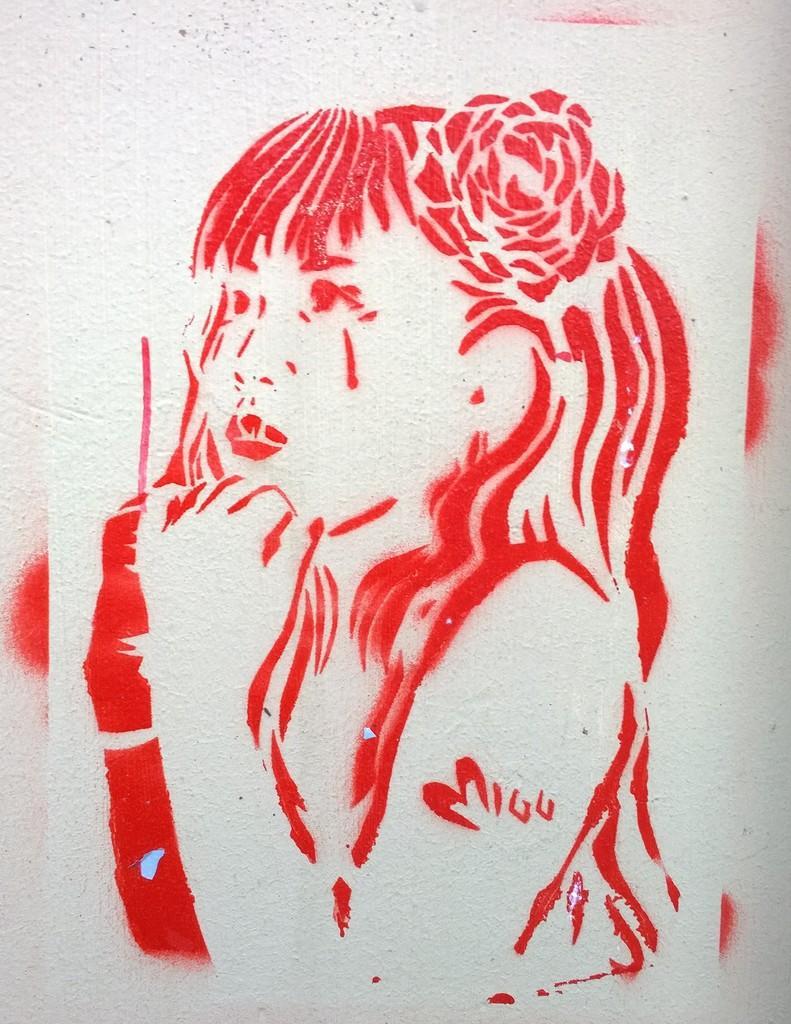In one or two sentences, can you explain what this image depicts? In this image we can see a painting of a woman on a wall. 